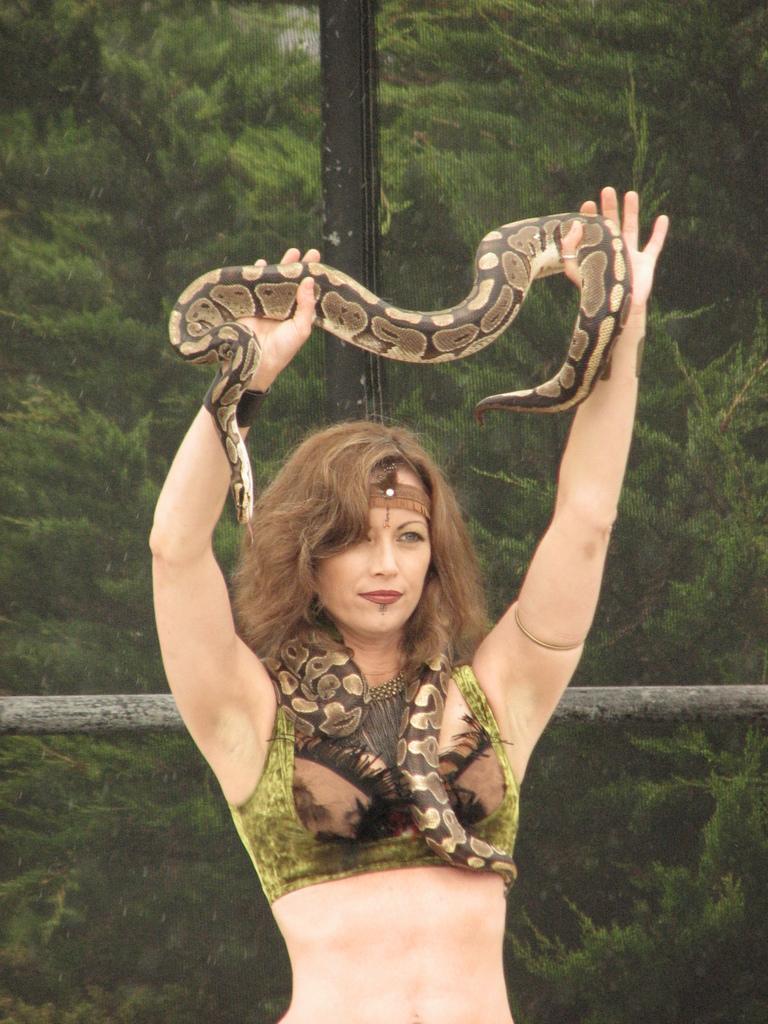Please provide a concise description of this image. In this image I see a woman who is standing and holding a snake in her hands, In the background I see a wooden pole. 